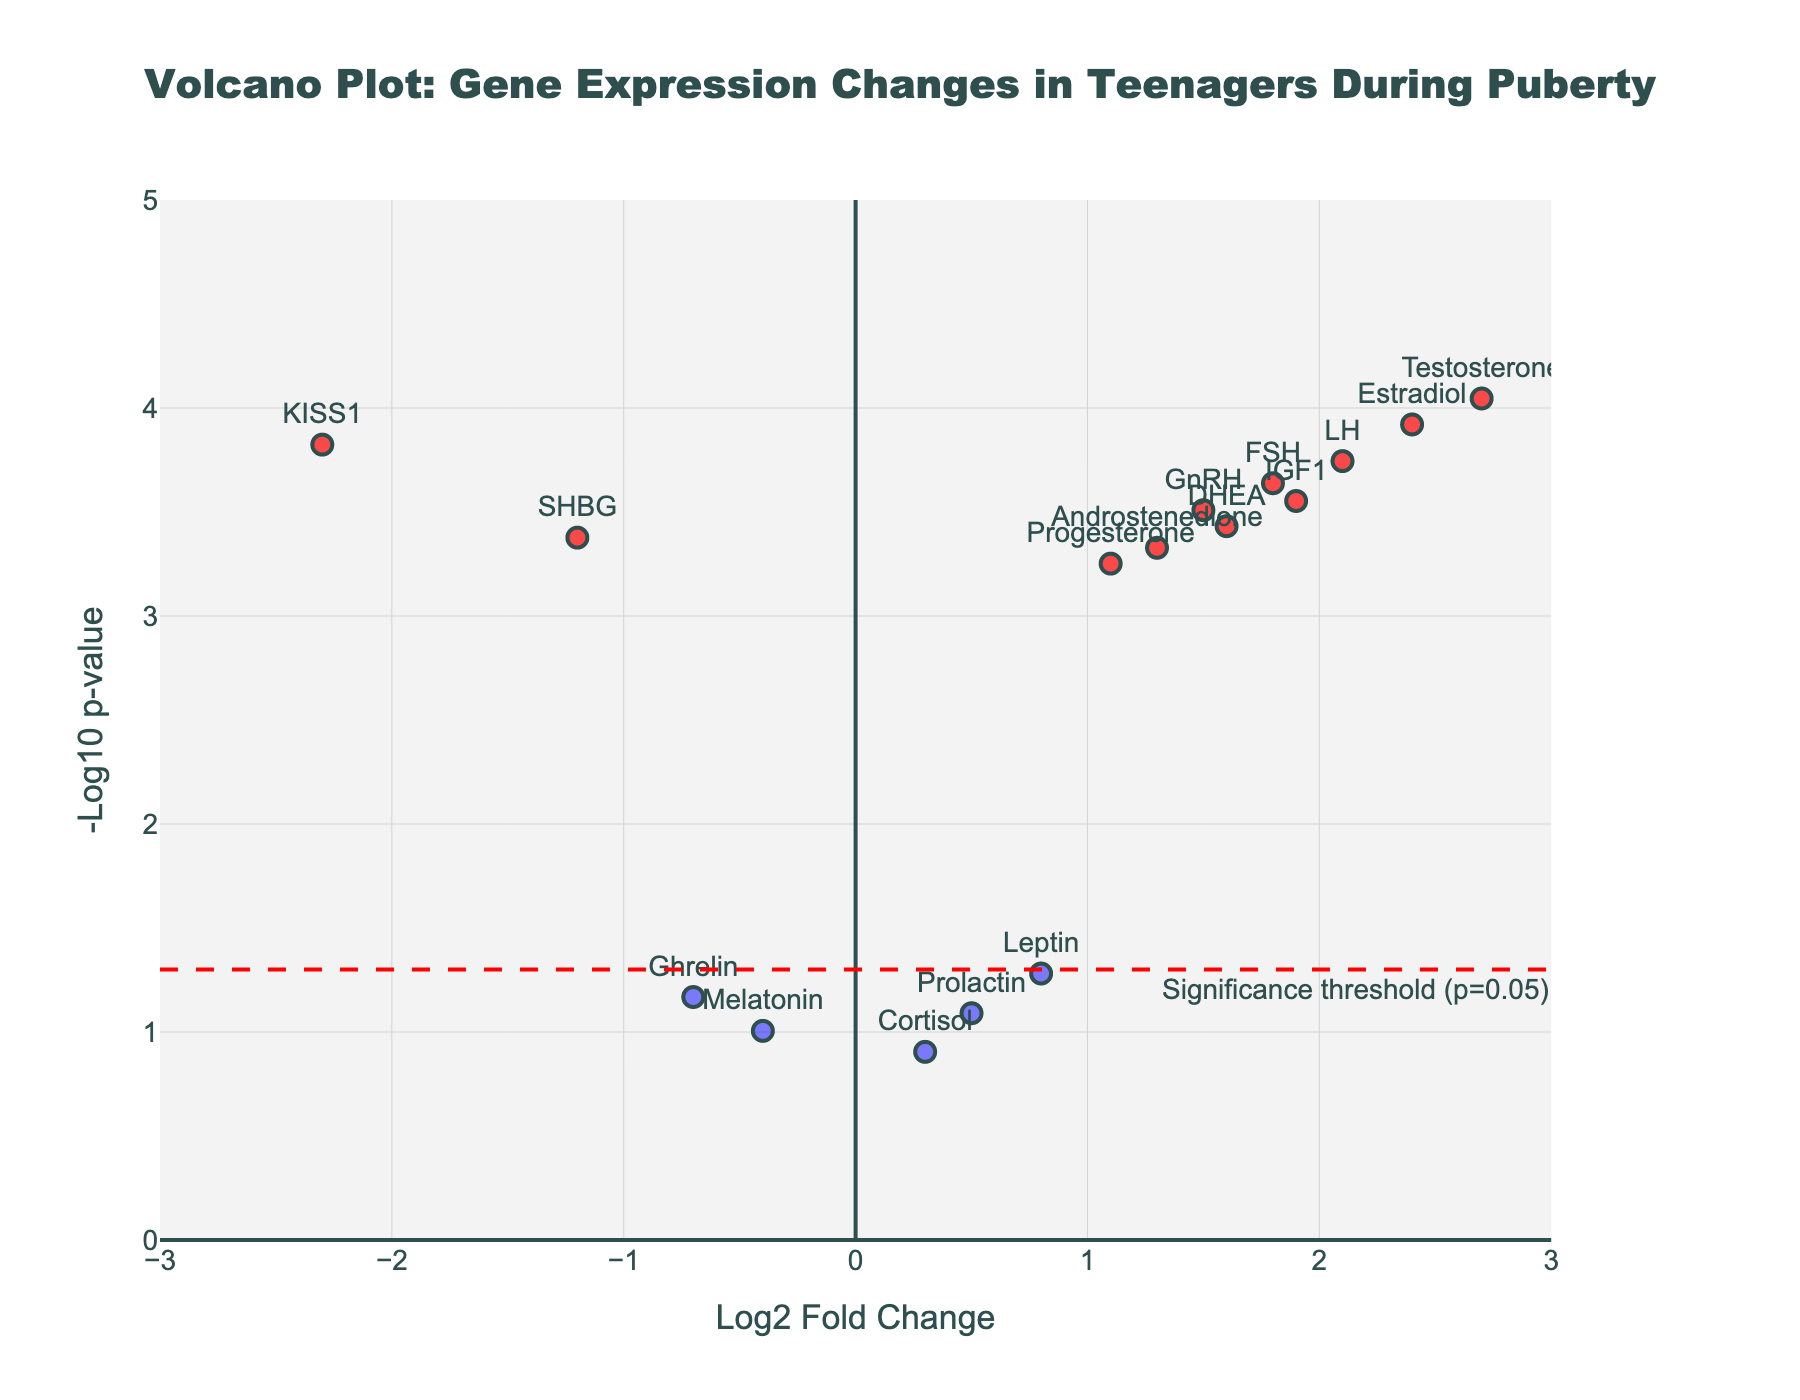What's the title of the plot? The title is positioned at the top center of the plot and is in a larger font size than other text elements.
Answer: Volcano Plot: Gene Expression Changes in Teenagers During Puberty What are the axis labels? The x-axis label is at the bottom of the horizontal axis and the y-axis label is along the vertical axis. The x-axis label is 'Log2 Fold Change' and the y-axis label is '-Log10 p-value'.
Answer: Log2 Fold Change and -Log10 p-value How many genes are classified as significant? Significant genes are represented by points colored in red. Counting these, there are 11 significant genes.
Answer: 11 Which gene has the highest log2 fold change? The gene with the highest log2 fold change appears farthest to the right on the x-axis. Testosterone has the highest log2 fold change value of 2.7.
Answer: Testosterone Which gene has the lowest p-value? Genes with the lowest p-value appear at the top of the y-axis. Testosterone, with the highest -log10 p-value (.00009), represents the lowest p-value.
Answer: Testosterone What is the significance threshold line for p-value? The threshold line is horizontal and annotated with its p-value significance threshold. The line is at y = -log10(0.05), which is approximately 1.3.
Answer: 1.3 Between KISS1 and FSH, which one has a more significant change in expression? A more significant change in expression can be determined by the higher -log10(p-value). KISS1 has a -log10(p-value) higher than FSH.
Answer: KISS1 In which quadrant is the SHBG gene located? The quadrant is determined by checking the sign of log2 fold change (x-axis) and the value of -log10(p-value) (y-axis). SHBG is in the lower left quadrant as it has a negative log2 fold change and significant p-value.
Answer: Lower left Which non-significant gene has the highest log2 fold change? Among non-significant genes, the one appearing farthest to the right on the x-axis has the highest log2 fold change. Leptin is the non-significant gene with the highest log2 fold change of 0.8.
Answer: Leptin Compare the expression change of Estradiol and Progesterone. Which is more upregulated? Upregulation is identified by a positive log2 fold change. Comparing Estradiol (2.4) with Progesterone (1.1), Estradiol is more upregulated.
Answer: Estradiol 